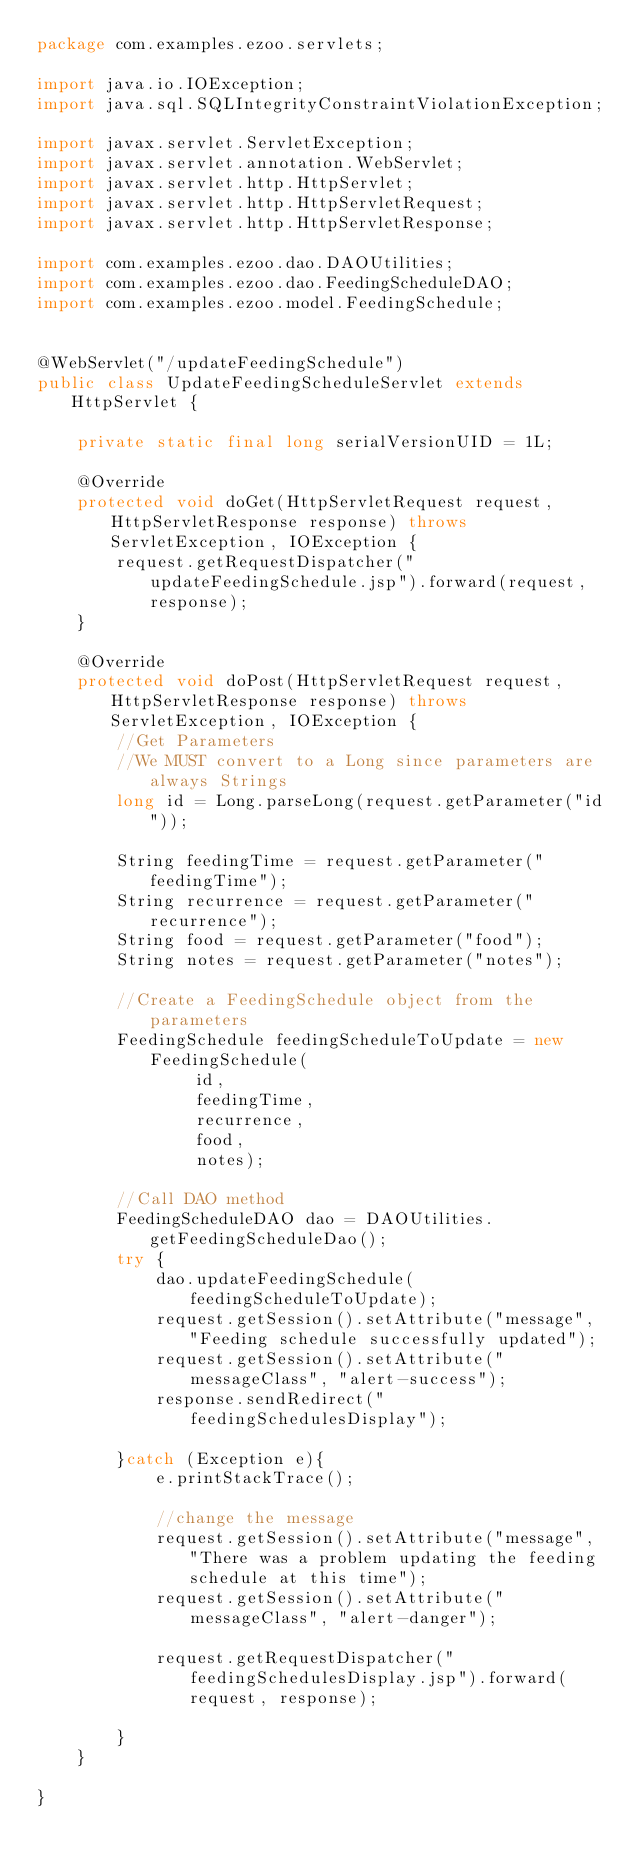<code> <loc_0><loc_0><loc_500><loc_500><_Java_>package com.examples.ezoo.servlets;

import java.io.IOException;
import java.sql.SQLIntegrityConstraintViolationException;

import javax.servlet.ServletException;
import javax.servlet.annotation.WebServlet;
import javax.servlet.http.HttpServlet;
import javax.servlet.http.HttpServletRequest;
import javax.servlet.http.HttpServletResponse;

import com.examples.ezoo.dao.DAOUtilities;
import com.examples.ezoo.dao.FeedingScheduleDAO;
import com.examples.ezoo.model.FeedingSchedule;


@WebServlet("/updateFeedingSchedule")
public class UpdateFeedingScheduleServlet extends HttpServlet {

	private static final long serialVersionUID = 1L;
    
    @Override
	protected void doGet(HttpServletRequest request, HttpServletResponse response) throws ServletException, IOException {
		request.getRequestDispatcher("updateFeedingSchedule.jsp").forward(request, response);
	}

    @Override
	protected void doPost(HttpServletRequest request, HttpServletResponse response) throws ServletException, IOException {
		//Get Parameters
		//We MUST convert to a Long since parameters are always Strings
		long id = Long.parseLong(request.getParameter("id"));
		
		String feedingTime = request.getParameter("feedingTime");
		String recurrence = request.getParameter("recurrence");
		String food = request.getParameter("food");
		String notes = request.getParameter("notes");
		
		//Create a FeedingSchedule object from the parameters
		FeedingSchedule feedingScheduleToUpdate = new FeedingSchedule(
				id, 
				feedingTime, 
				recurrence,
				food,
				notes);
		
		//Call DAO method
		FeedingScheduleDAO dao = DAOUtilities.getFeedingScheduleDao();
		try {
			dao.updateFeedingSchedule(feedingScheduleToUpdate);
			request.getSession().setAttribute("message", "Feeding schedule successfully updated");
			request.getSession().setAttribute("messageClass", "alert-success");
			response.sendRedirect("feedingSchedulesDisplay");

		}catch (Exception e){
			e.printStackTrace();
			
			//change the message
			request.getSession().setAttribute("message", "There was a problem updating the feeding schedule at this time");
			request.getSession().setAttribute("messageClass", "alert-danger");
			
			request.getRequestDispatcher("feedingSchedulesDisplay.jsp").forward(request, response);

		}
	}	

}
</code> 